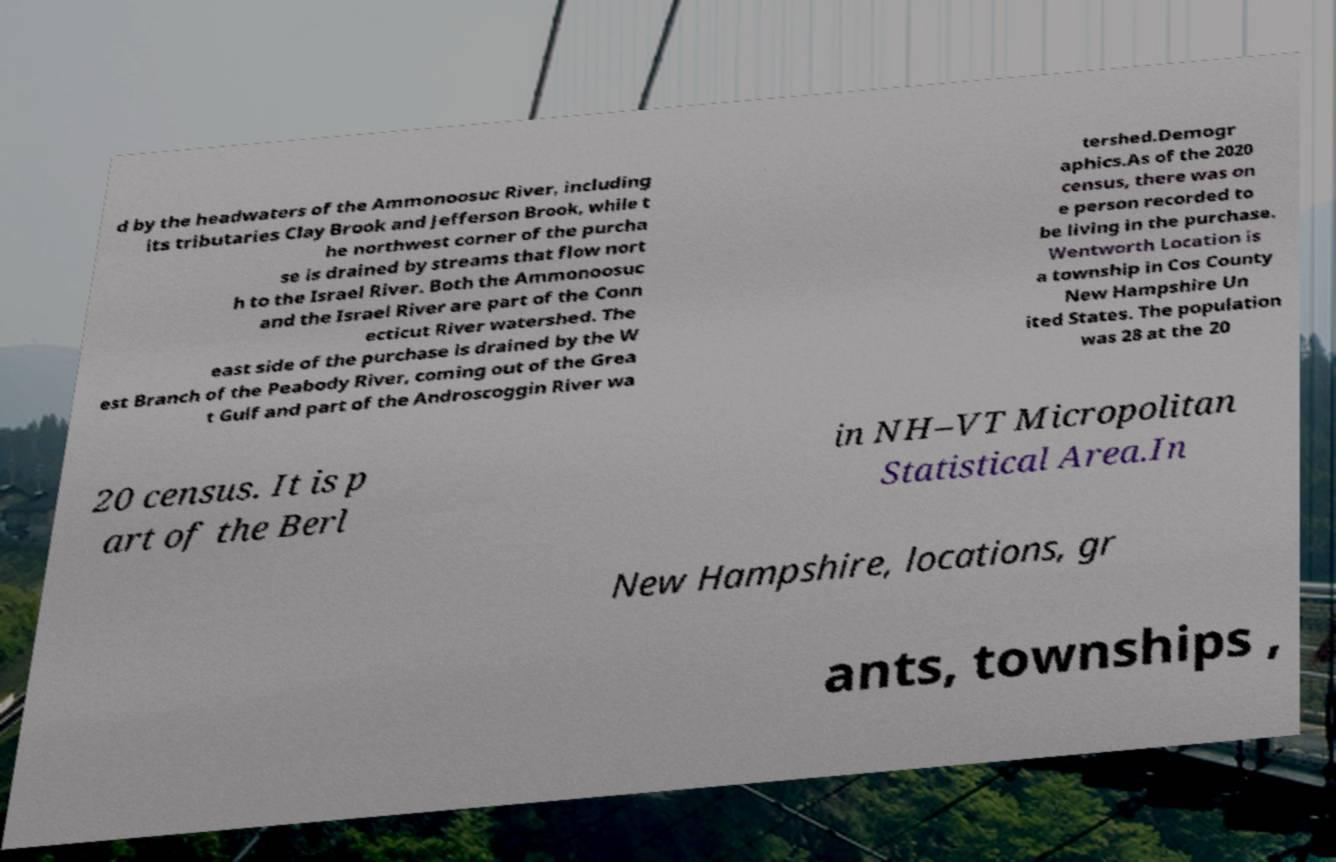I need the written content from this picture converted into text. Can you do that? d by the headwaters of the Ammonoosuc River, including its tributaries Clay Brook and Jefferson Brook, while t he northwest corner of the purcha se is drained by streams that flow nort h to the Israel River. Both the Ammonoosuc and the Israel River are part of the Conn ecticut River watershed. The east side of the purchase is drained by the W est Branch of the Peabody River, coming out of the Grea t Gulf and part of the Androscoggin River wa tershed.Demogr aphics.As of the 2020 census, there was on e person recorded to be living in the purchase. Wentworth Location is a township in Cos County New Hampshire Un ited States. The population was 28 at the 20 20 census. It is p art of the Berl in NH–VT Micropolitan Statistical Area.In New Hampshire, locations, gr ants, townships , 